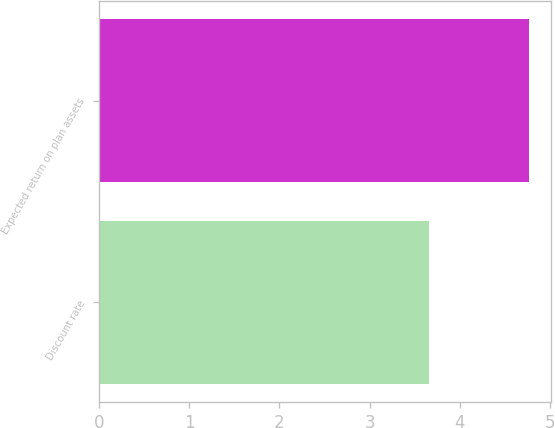Convert chart. <chart><loc_0><loc_0><loc_500><loc_500><bar_chart><fcel>Discount rate<fcel>Expected return on plan assets<nl><fcel>3.66<fcel>4.77<nl></chart> 